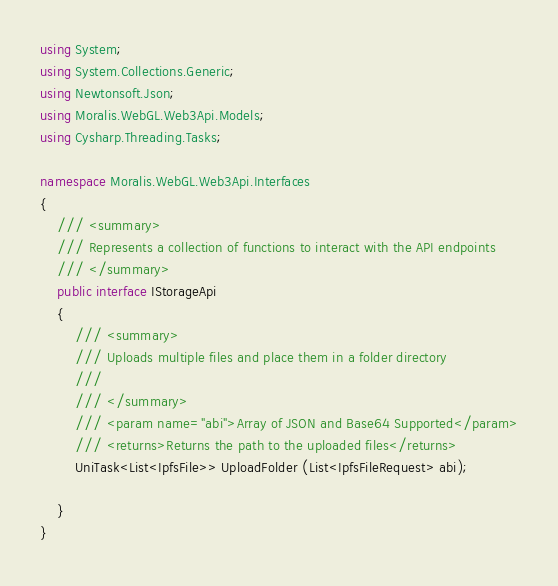Convert code to text. <code><loc_0><loc_0><loc_500><loc_500><_C#_>using System;
using System.Collections.Generic;
using Newtonsoft.Json;
using Moralis.WebGL.Web3Api.Models;
using Cysharp.Threading.Tasks;

namespace Moralis.WebGL.Web3Api.Interfaces
{
	/// <summary>
	/// Represents a collection of functions to interact with the API endpoints
	/// </summary>
	public interface IStorageApi
	{
		/// <summary>
		/// Uploads multiple files and place them in a folder directory
		/// 
		/// </summary>
		/// <param name="abi">Array of JSON and Base64 Supported</param>
		/// <returns>Returns the path to the uploaded files</returns>
		UniTask<List<IpfsFile>> UploadFolder (List<IpfsFileRequest> abi);

	}
}
</code> 